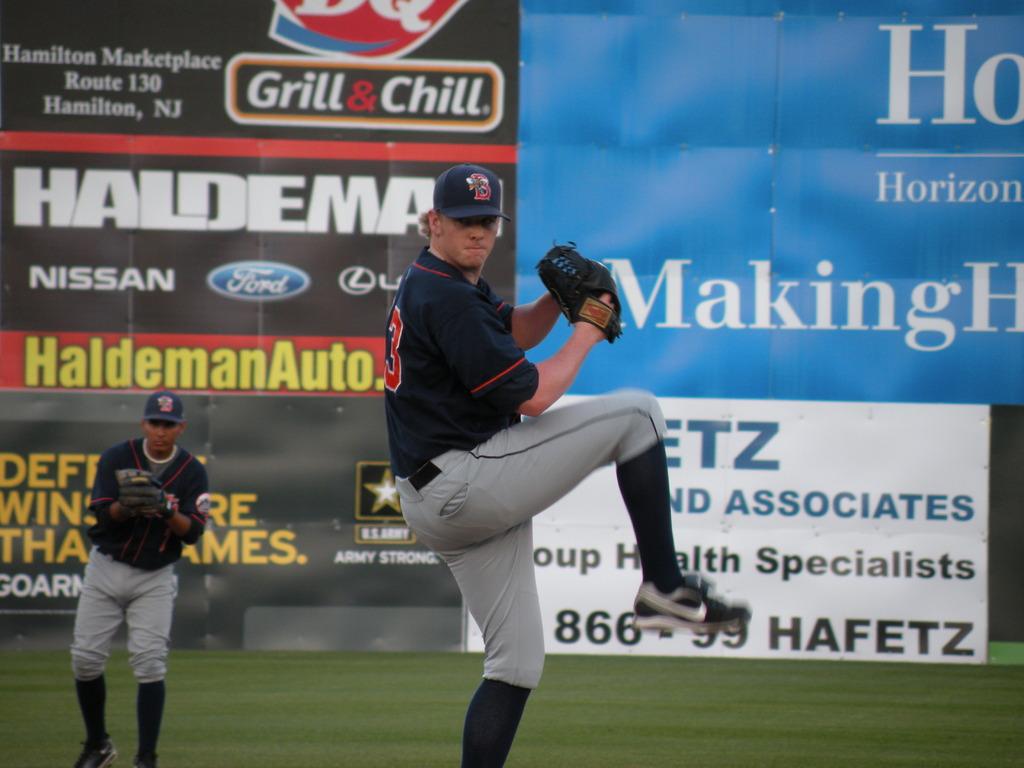What advertiser is there?
Provide a succinct answer. Dq. 